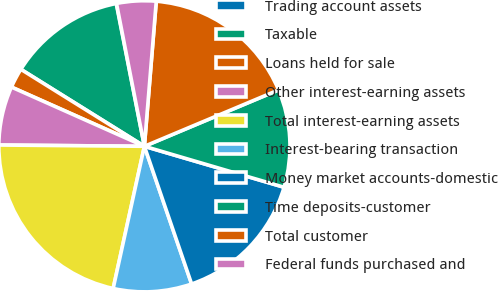Convert chart. <chart><loc_0><loc_0><loc_500><loc_500><pie_chart><fcel>Trading account assets<fcel>Taxable<fcel>Loans held for sale<fcel>Other interest-earning assets<fcel>Total interest-earning assets<fcel>Interest-bearing transaction<fcel>Money market accounts-domestic<fcel>Time deposits-customer<fcel>Total customer<fcel>Federal funds purchased and<nl><fcel>0.03%<fcel>13.03%<fcel>2.2%<fcel>6.53%<fcel>21.7%<fcel>8.7%<fcel>15.2%<fcel>10.87%<fcel>17.37%<fcel>4.37%<nl></chart> 